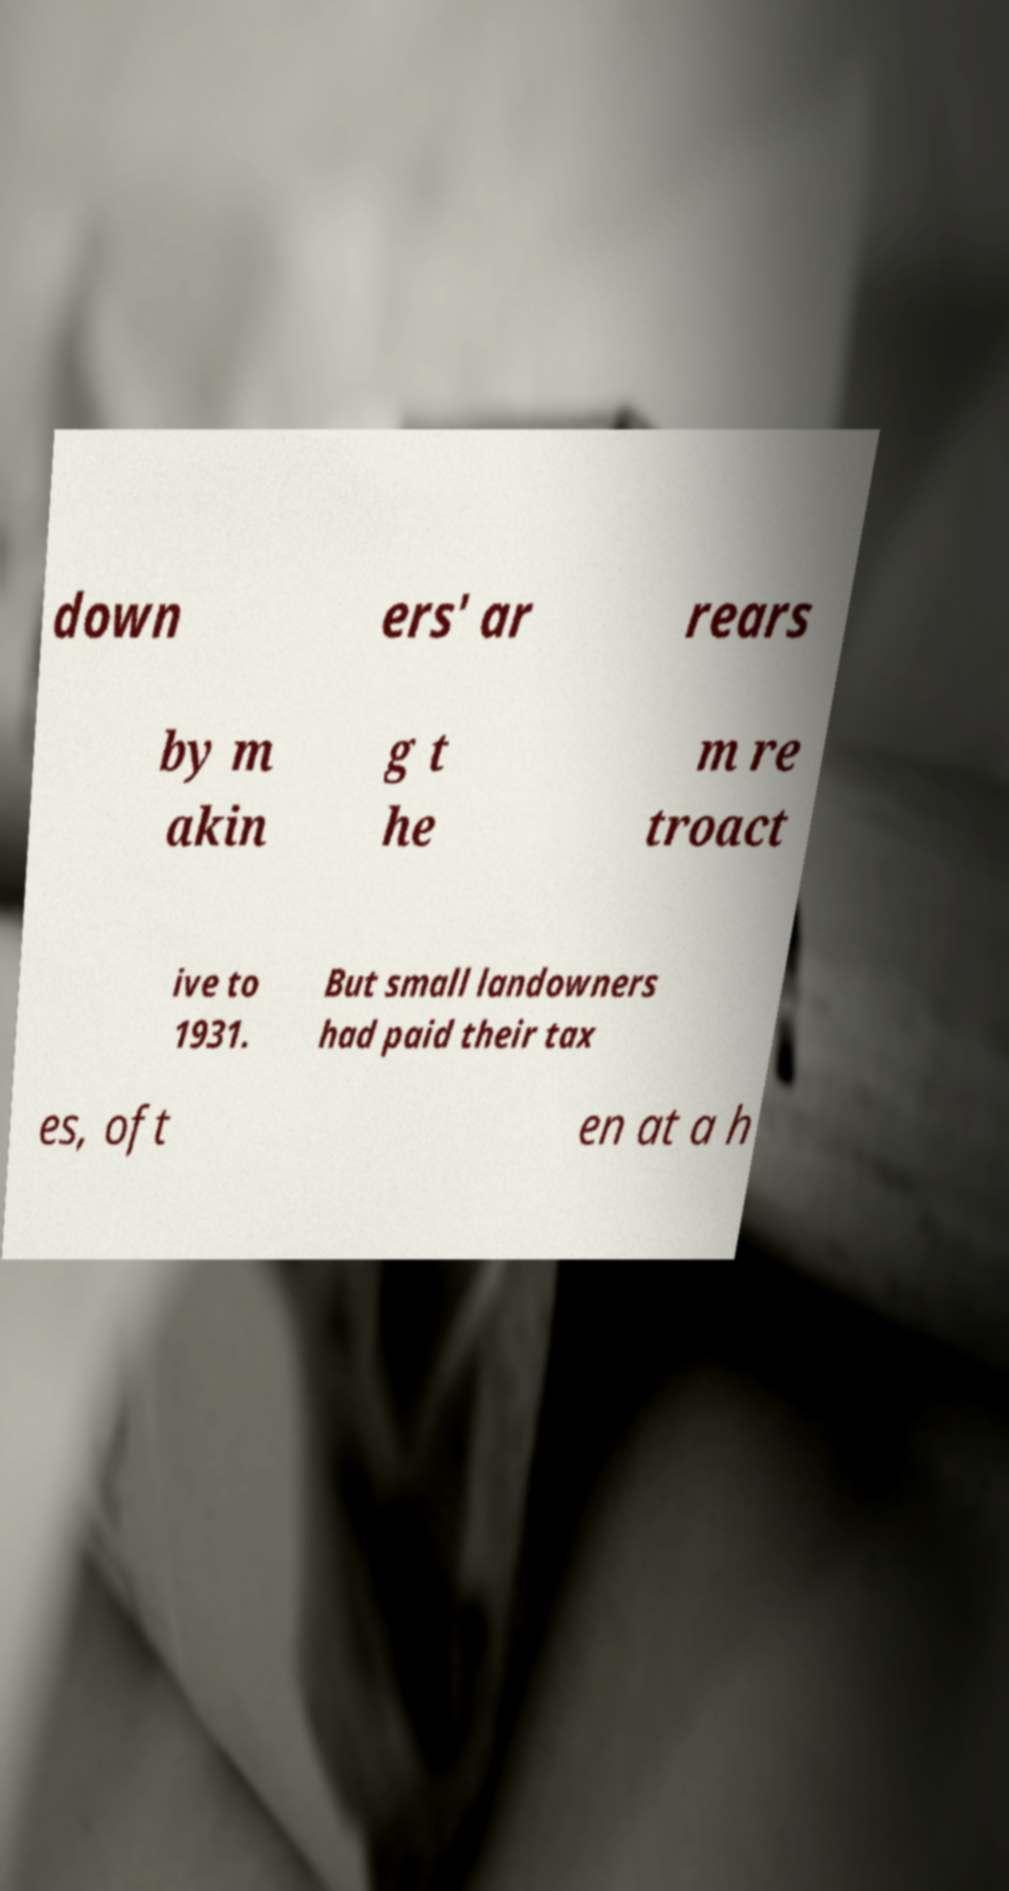What messages or text are displayed in this image? I need them in a readable, typed format. down ers' ar rears by m akin g t he m re troact ive to 1931. But small landowners had paid their tax es, oft en at a h 